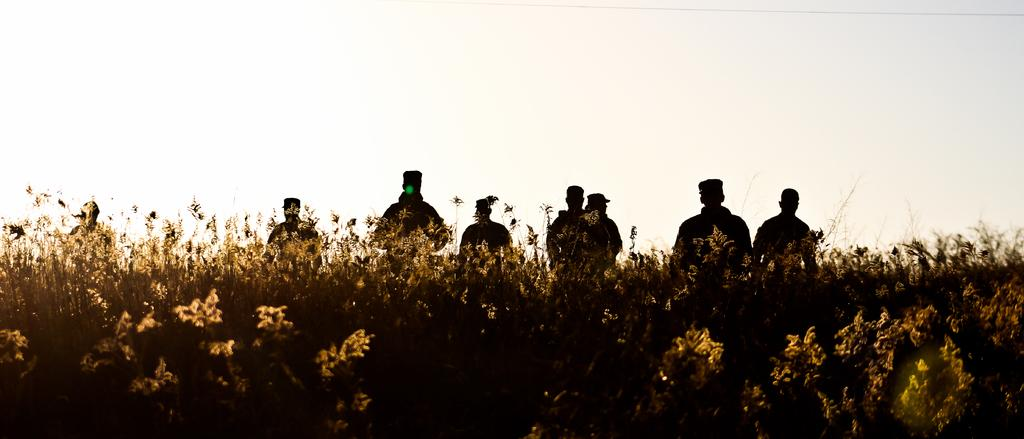What is happening in the image? There is a group of people standing in the image. What can be seen in the foreground of the image? There are plants in the foreground of the image. What is visible at the top of the image? The sky is visible at the top of the image. What is the income of the people in the image? There is no information about the income of the people in the image. How does the gold appear in the image? There is no gold present in the image. 